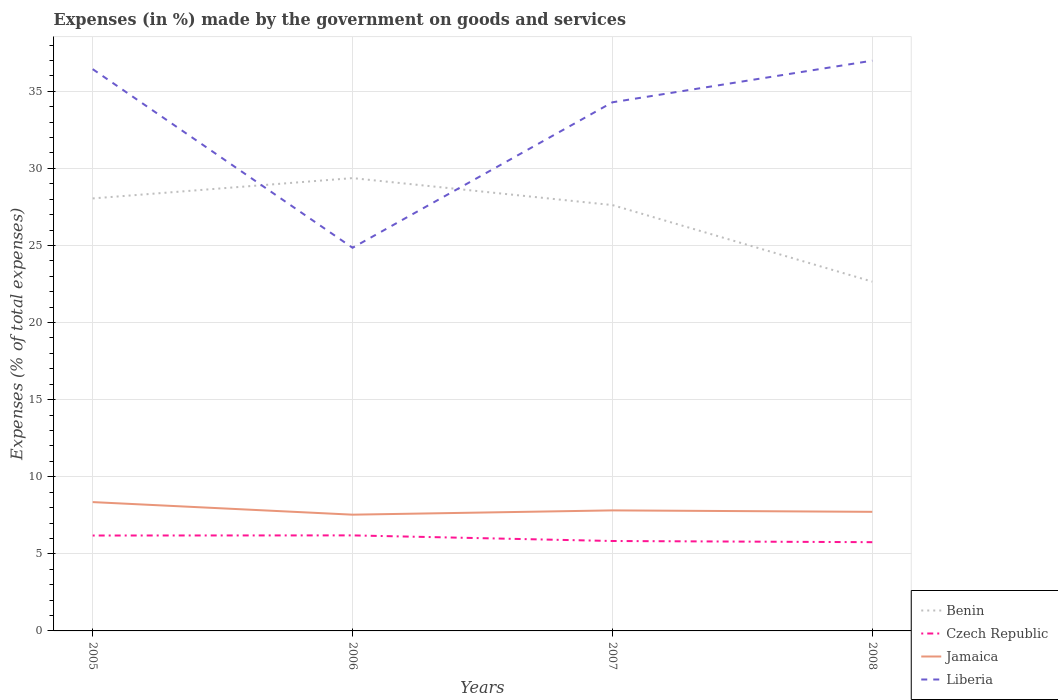How many different coloured lines are there?
Your answer should be very brief. 4. Does the line corresponding to Czech Republic intersect with the line corresponding to Benin?
Ensure brevity in your answer.  No. Across all years, what is the maximum percentage of expenses made by the government on goods and services in Jamaica?
Your answer should be very brief. 7.54. In which year was the percentage of expenses made by the government on goods and services in Czech Republic maximum?
Offer a very short reply. 2008. What is the total percentage of expenses made by the government on goods and services in Czech Republic in the graph?
Your response must be concise. 0.08. What is the difference between the highest and the second highest percentage of expenses made by the government on goods and services in Czech Republic?
Provide a succinct answer. 0.44. What is the difference between the highest and the lowest percentage of expenses made by the government on goods and services in Benin?
Keep it short and to the point. 3. How many lines are there?
Your answer should be very brief. 4. What is the difference between two consecutive major ticks on the Y-axis?
Offer a terse response. 5. Are the values on the major ticks of Y-axis written in scientific E-notation?
Your answer should be very brief. No. Does the graph contain any zero values?
Offer a very short reply. No. Does the graph contain grids?
Your answer should be very brief. Yes. Where does the legend appear in the graph?
Provide a short and direct response. Bottom right. How many legend labels are there?
Give a very brief answer. 4. What is the title of the graph?
Give a very brief answer. Expenses (in %) made by the government on goods and services. Does "Ghana" appear as one of the legend labels in the graph?
Offer a terse response. No. What is the label or title of the X-axis?
Offer a terse response. Years. What is the label or title of the Y-axis?
Your answer should be compact. Expenses (% of total expenses). What is the Expenses (% of total expenses) in Benin in 2005?
Ensure brevity in your answer.  28.05. What is the Expenses (% of total expenses) of Czech Republic in 2005?
Offer a terse response. 6.19. What is the Expenses (% of total expenses) of Jamaica in 2005?
Offer a very short reply. 8.36. What is the Expenses (% of total expenses) in Liberia in 2005?
Ensure brevity in your answer.  36.44. What is the Expenses (% of total expenses) of Benin in 2006?
Make the answer very short. 29.37. What is the Expenses (% of total expenses) in Czech Republic in 2006?
Provide a short and direct response. 6.2. What is the Expenses (% of total expenses) in Jamaica in 2006?
Provide a short and direct response. 7.54. What is the Expenses (% of total expenses) of Liberia in 2006?
Keep it short and to the point. 24.85. What is the Expenses (% of total expenses) of Benin in 2007?
Provide a short and direct response. 27.62. What is the Expenses (% of total expenses) of Czech Republic in 2007?
Your response must be concise. 5.83. What is the Expenses (% of total expenses) of Jamaica in 2007?
Provide a short and direct response. 7.82. What is the Expenses (% of total expenses) in Liberia in 2007?
Offer a terse response. 34.29. What is the Expenses (% of total expenses) in Benin in 2008?
Provide a short and direct response. 22.66. What is the Expenses (% of total expenses) in Czech Republic in 2008?
Keep it short and to the point. 5.76. What is the Expenses (% of total expenses) of Jamaica in 2008?
Keep it short and to the point. 7.72. What is the Expenses (% of total expenses) in Liberia in 2008?
Offer a very short reply. 36.99. Across all years, what is the maximum Expenses (% of total expenses) in Benin?
Keep it short and to the point. 29.37. Across all years, what is the maximum Expenses (% of total expenses) in Czech Republic?
Ensure brevity in your answer.  6.2. Across all years, what is the maximum Expenses (% of total expenses) of Jamaica?
Ensure brevity in your answer.  8.36. Across all years, what is the maximum Expenses (% of total expenses) of Liberia?
Your response must be concise. 36.99. Across all years, what is the minimum Expenses (% of total expenses) in Benin?
Offer a very short reply. 22.66. Across all years, what is the minimum Expenses (% of total expenses) of Czech Republic?
Offer a terse response. 5.76. Across all years, what is the minimum Expenses (% of total expenses) in Jamaica?
Provide a succinct answer. 7.54. Across all years, what is the minimum Expenses (% of total expenses) of Liberia?
Provide a succinct answer. 24.85. What is the total Expenses (% of total expenses) in Benin in the graph?
Ensure brevity in your answer.  107.7. What is the total Expenses (% of total expenses) in Czech Republic in the graph?
Your answer should be compact. 23.97. What is the total Expenses (% of total expenses) in Jamaica in the graph?
Provide a succinct answer. 31.44. What is the total Expenses (% of total expenses) in Liberia in the graph?
Provide a short and direct response. 132.57. What is the difference between the Expenses (% of total expenses) in Benin in 2005 and that in 2006?
Provide a short and direct response. -1.32. What is the difference between the Expenses (% of total expenses) of Czech Republic in 2005 and that in 2006?
Offer a very short reply. -0.01. What is the difference between the Expenses (% of total expenses) in Jamaica in 2005 and that in 2006?
Offer a very short reply. 0.82. What is the difference between the Expenses (% of total expenses) in Liberia in 2005 and that in 2006?
Your response must be concise. 11.59. What is the difference between the Expenses (% of total expenses) in Benin in 2005 and that in 2007?
Your response must be concise. 0.43. What is the difference between the Expenses (% of total expenses) in Czech Republic in 2005 and that in 2007?
Your answer should be compact. 0.36. What is the difference between the Expenses (% of total expenses) in Jamaica in 2005 and that in 2007?
Your answer should be very brief. 0.54. What is the difference between the Expenses (% of total expenses) of Liberia in 2005 and that in 2007?
Make the answer very short. 2.15. What is the difference between the Expenses (% of total expenses) in Benin in 2005 and that in 2008?
Provide a succinct answer. 5.4. What is the difference between the Expenses (% of total expenses) in Czech Republic in 2005 and that in 2008?
Give a very brief answer. 0.43. What is the difference between the Expenses (% of total expenses) in Jamaica in 2005 and that in 2008?
Offer a very short reply. 0.63. What is the difference between the Expenses (% of total expenses) in Liberia in 2005 and that in 2008?
Provide a succinct answer. -0.55. What is the difference between the Expenses (% of total expenses) in Benin in 2006 and that in 2007?
Your answer should be compact. 1.75. What is the difference between the Expenses (% of total expenses) of Czech Republic in 2006 and that in 2007?
Offer a terse response. 0.36. What is the difference between the Expenses (% of total expenses) of Jamaica in 2006 and that in 2007?
Provide a short and direct response. -0.28. What is the difference between the Expenses (% of total expenses) of Liberia in 2006 and that in 2007?
Provide a succinct answer. -9.44. What is the difference between the Expenses (% of total expenses) in Benin in 2006 and that in 2008?
Your response must be concise. 6.71. What is the difference between the Expenses (% of total expenses) in Czech Republic in 2006 and that in 2008?
Offer a very short reply. 0.44. What is the difference between the Expenses (% of total expenses) of Jamaica in 2006 and that in 2008?
Your response must be concise. -0.18. What is the difference between the Expenses (% of total expenses) of Liberia in 2006 and that in 2008?
Your response must be concise. -12.14. What is the difference between the Expenses (% of total expenses) in Benin in 2007 and that in 2008?
Your answer should be very brief. 4.97. What is the difference between the Expenses (% of total expenses) in Czech Republic in 2007 and that in 2008?
Ensure brevity in your answer.  0.08. What is the difference between the Expenses (% of total expenses) of Jamaica in 2007 and that in 2008?
Make the answer very short. 0.09. What is the difference between the Expenses (% of total expenses) of Liberia in 2007 and that in 2008?
Ensure brevity in your answer.  -2.7. What is the difference between the Expenses (% of total expenses) in Benin in 2005 and the Expenses (% of total expenses) in Czech Republic in 2006?
Keep it short and to the point. 21.86. What is the difference between the Expenses (% of total expenses) of Benin in 2005 and the Expenses (% of total expenses) of Jamaica in 2006?
Ensure brevity in your answer.  20.51. What is the difference between the Expenses (% of total expenses) in Benin in 2005 and the Expenses (% of total expenses) in Liberia in 2006?
Keep it short and to the point. 3.2. What is the difference between the Expenses (% of total expenses) in Czech Republic in 2005 and the Expenses (% of total expenses) in Jamaica in 2006?
Offer a very short reply. -1.35. What is the difference between the Expenses (% of total expenses) in Czech Republic in 2005 and the Expenses (% of total expenses) in Liberia in 2006?
Provide a succinct answer. -18.66. What is the difference between the Expenses (% of total expenses) in Jamaica in 2005 and the Expenses (% of total expenses) in Liberia in 2006?
Provide a short and direct response. -16.5. What is the difference between the Expenses (% of total expenses) in Benin in 2005 and the Expenses (% of total expenses) in Czech Republic in 2007?
Ensure brevity in your answer.  22.22. What is the difference between the Expenses (% of total expenses) in Benin in 2005 and the Expenses (% of total expenses) in Jamaica in 2007?
Make the answer very short. 20.23. What is the difference between the Expenses (% of total expenses) in Benin in 2005 and the Expenses (% of total expenses) in Liberia in 2007?
Ensure brevity in your answer.  -6.24. What is the difference between the Expenses (% of total expenses) of Czech Republic in 2005 and the Expenses (% of total expenses) of Jamaica in 2007?
Keep it short and to the point. -1.63. What is the difference between the Expenses (% of total expenses) of Czech Republic in 2005 and the Expenses (% of total expenses) of Liberia in 2007?
Offer a terse response. -28.1. What is the difference between the Expenses (% of total expenses) of Jamaica in 2005 and the Expenses (% of total expenses) of Liberia in 2007?
Your response must be concise. -25.93. What is the difference between the Expenses (% of total expenses) of Benin in 2005 and the Expenses (% of total expenses) of Czech Republic in 2008?
Provide a succinct answer. 22.3. What is the difference between the Expenses (% of total expenses) in Benin in 2005 and the Expenses (% of total expenses) in Jamaica in 2008?
Keep it short and to the point. 20.33. What is the difference between the Expenses (% of total expenses) in Benin in 2005 and the Expenses (% of total expenses) in Liberia in 2008?
Give a very brief answer. -8.94. What is the difference between the Expenses (% of total expenses) in Czech Republic in 2005 and the Expenses (% of total expenses) in Jamaica in 2008?
Provide a short and direct response. -1.54. What is the difference between the Expenses (% of total expenses) in Czech Republic in 2005 and the Expenses (% of total expenses) in Liberia in 2008?
Provide a succinct answer. -30.8. What is the difference between the Expenses (% of total expenses) in Jamaica in 2005 and the Expenses (% of total expenses) in Liberia in 2008?
Keep it short and to the point. -28.63. What is the difference between the Expenses (% of total expenses) of Benin in 2006 and the Expenses (% of total expenses) of Czech Republic in 2007?
Offer a very short reply. 23.54. What is the difference between the Expenses (% of total expenses) in Benin in 2006 and the Expenses (% of total expenses) in Jamaica in 2007?
Give a very brief answer. 21.55. What is the difference between the Expenses (% of total expenses) of Benin in 2006 and the Expenses (% of total expenses) of Liberia in 2007?
Provide a succinct answer. -4.92. What is the difference between the Expenses (% of total expenses) of Czech Republic in 2006 and the Expenses (% of total expenses) of Jamaica in 2007?
Make the answer very short. -1.62. What is the difference between the Expenses (% of total expenses) in Czech Republic in 2006 and the Expenses (% of total expenses) in Liberia in 2007?
Offer a terse response. -28.09. What is the difference between the Expenses (% of total expenses) of Jamaica in 2006 and the Expenses (% of total expenses) of Liberia in 2007?
Give a very brief answer. -26.75. What is the difference between the Expenses (% of total expenses) of Benin in 2006 and the Expenses (% of total expenses) of Czech Republic in 2008?
Your answer should be very brief. 23.61. What is the difference between the Expenses (% of total expenses) in Benin in 2006 and the Expenses (% of total expenses) in Jamaica in 2008?
Offer a very short reply. 21.65. What is the difference between the Expenses (% of total expenses) of Benin in 2006 and the Expenses (% of total expenses) of Liberia in 2008?
Keep it short and to the point. -7.62. What is the difference between the Expenses (% of total expenses) in Czech Republic in 2006 and the Expenses (% of total expenses) in Jamaica in 2008?
Your response must be concise. -1.53. What is the difference between the Expenses (% of total expenses) in Czech Republic in 2006 and the Expenses (% of total expenses) in Liberia in 2008?
Make the answer very short. -30.79. What is the difference between the Expenses (% of total expenses) of Jamaica in 2006 and the Expenses (% of total expenses) of Liberia in 2008?
Your answer should be very brief. -29.45. What is the difference between the Expenses (% of total expenses) of Benin in 2007 and the Expenses (% of total expenses) of Czech Republic in 2008?
Ensure brevity in your answer.  21.87. What is the difference between the Expenses (% of total expenses) of Benin in 2007 and the Expenses (% of total expenses) of Jamaica in 2008?
Provide a short and direct response. 19.9. What is the difference between the Expenses (% of total expenses) in Benin in 2007 and the Expenses (% of total expenses) in Liberia in 2008?
Ensure brevity in your answer.  -9.37. What is the difference between the Expenses (% of total expenses) of Czech Republic in 2007 and the Expenses (% of total expenses) of Jamaica in 2008?
Give a very brief answer. -1.89. What is the difference between the Expenses (% of total expenses) in Czech Republic in 2007 and the Expenses (% of total expenses) in Liberia in 2008?
Offer a terse response. -31.16. What is the difference between the Expenses (% of total expenses) in Jamaica in 2007 and the Expenses (% of total expenses) in Liberia in 2008?
Give a very brief answer. -29.17. What is the average Expenses (% of total expenses) in Benin per year?
Ensure brevity in your answer.  26.93. What is the average Expenses (% of total expenses) in Czech Republic per year?
Provide a succinct answer. 5.99. What is the average Expenses (% of total expenses) in Jamaica per year?
Your answer should be compact. 7.86. What is the average Expenses (% of total expenses) of Liberia per year?
Provide a succinct answer. 33.14. In the year 2005, what is the difference between the Expenses (% of total expenses) of Benin and Expenses (% of total expenses) of Czech Republic?
Provide a succinct answer. 21.86. In the year 2005, what is the difference between the Expenses (% of total expenses) in Benin and Expenses (% of total expenses) in Jamaica?
Offer a very short reply. 19.7. In the year 2005, what is the difference between the Expenses (% of total expenses) of Benin and Expenses (% of total expenses) of Liberia?
Give a very brief answer. -8.39. In the year 2005, what is the difference between the Expenses (% of total expenses) in Czech Republic and Expenses (% of total expenses) in Jamaica?
Your response must be concise. -2.17. In the year 2005, what is the difference between the Expenses (% of total expenses) in Czech Republic and Expenses (% of total expenses) in Liberia?
Provide a succinct answer. -30.25. In the year 2005, what is the difference between the Expenses (% of total expenses) in Jamaica and Expenses (% of total expenses) in Liberia?
Offer a terse response. -28.08. In the year 2006, what is the difference between the Expenses (% of total expenses) in Benin and Expenses (% of total expenses) in Czech Republic?
Make the answer very short. 23.17. In the year 2006, what is the difference between the Expenses (% of total expenses) of Benin and Expenses (% of total expenses) of Jamaica?
Offer a terse response. 21.83. In the year 2006, what is the difference between the Expenses (% of total expenses) in Benin and Expenses (% of total expenses) in Liberia?
Provide a short and direct response. 4.52. In the year 2006, what is the difference between the Expenses (% of total expenses) in Czech Republic and Expenses (% of total expenses) in Jamaica?
Ensure brevity in your answer.  -1.34. In the year 2006, what is the difference between the Expenses (% of total expenses) of Czech Republic and Expenses (% of total expenses) of Liberia?
Provide a short and direct response. -18.66. In the year 2006, what is the difference between the Expenses (% of total expenses) of Jamaica and Expenses (% of total expenses) of Liberia?
Give a very brief answer. -17.31. In the year 2007, what is the difference between the Expenses (% of total expenses) in Benin and Expenses (% of total expenses) in Czech Republic?
Your response must be concise. 21.79. In the year 2007, what is the difference between the Expenses (% of total expenses) of Benin and Expenses (% of total expenses) of Jamaica?
Your answer should be compact. 19.8. In the year 2007, what is the difference between the Expenses (% of total expenses) of Benin and Expenses (% of total expenses) of Liberia?
Make the answer very short. -6.67. In the year 2007, what is the difference between the Expenses (% of total expenses) in Czech Republic and Expenses (% of total expenses) in Jamaica?
Your response must be concise. -1.99. In the year 2007, what is the difference between the Expenses (% of total expenses) in Czech Republic and Expenses (% of total expenses) in Liberia?
Give a very brief answer. -28.46. In the year 2007, what is the difference between the Expenses (% of total expenses) of Jamaica and Expenses (% of total expenses) of Liberia?
Ensure brevity in your answer.  -26.47. In the year 2008, what is the difference between the Expenses (% of total expenses) in Benin and Expenses (% of total expenses) in Czech Republic?
Offer a terse response. 16.9. In the year 2008, what is the difference between the Expenses (% of total expenses) of Benin and Expenses (% of total expenses) of Jamaica?
Offer a very short reply. 14.93. In the year 2008, what is the difference between the Expenses (% of total expenses) in Benin and Expenses (% of total expenses) in Liberia?
Provide a succinct answer. -14.33. In the year 2008, what is the difference between the Expenses (% of total expenses) in Czech Republic and Expenses (% of total expenses) in Jamaica?
Your answer should be very brief. -1.97. In the year 2008, what is the difference between the Expenses (% of total expenses) of Czech Republic and Expenses (% of total expenses) of Liberia?
Offer a terse response. -31.23. In the year 2008, what is the difference between the Expenses (% of total expenses) of Jamaica and Expenses (% of total expenses) of Liberia?
Keep it short and to the point. -29.26. What is the ratio of the Expenses (% of total expenses) of Benin in 2005 to that in 2006?
Make the answer very short. 0.96. What is the ratio of the Expenses (% of total expenses) of Czech Republic in 2005 to that in 2006?
Make the answer very short. 1. What is the ratio of the Expenses (% of total expenses) of Jamaica in 2005 to that in 2006?
Provide a short and direct response. 1.11. What is the ratio of the Expenses (% of total expenses) of Liberia in 2005 to that in 2006?
Your answer should be compact. 1.47. What is the ratio of the Expenses (% of total expenses) in Benin in 2005 to that in 2007?
Make the answer very short. 1.02. What is the ratio of the Expenses (% of total expenses) in Czech Republic in 2005 to that in 2007?
Offer a very short reply. 1.06. What is the ratio of the Expenses (% of total expenses) in Jamaica in 2005 to that in 2007?
Make the answer very short. 1.07. What is the ratio of the Expenses (% of total expenses) of Liberia in 2005 to that in 2007?
Offer a very short reply. 1.06. What is the ratio of the Expenses (% of total expenses) of Benin in 2005 to that in 2008?
Offer a terse response. 1.24. What is the ratio of the Expenses (% of total expenses) in Czech Republic in 2005 to that in 2008?
Keep it short and to the point. 1.07. What is the ratio of the Expenses (% of total expenses) in Jamaica in 2005 to that in 2008?
Offer a terse response. 1.08. What is the ratio of the Expenses (% of total expenses) in Liberia in 2005 to that in 2008?
Keep it short and to the point. 0.99. What is the ratio of the Expenses (% of total expenses) of Benin in 2006 to that in 2007?
Provide a short and direct response. 1.06. What is the ratio of the Expenses (% of total expenses) in Czech Republic in 2006 to that in 2007?
Your answer should be very brief. 1.06. What is the ratio of the Expenses (% of total expenses) of Jamaica in 2006 to that in 2007?
Offer a terse response. 0.96. What is the ratio of the Expenses (% of total expenses) in Liberia in 2006 to that in 2007?
Make the answer very short. 0.72. What is the ratio of the Expenses (% of total expenses) of Benin in 2006 to that in 2008?
Your answer should be compact. 1.3. What is the ratio of the Expenses (% of total expenses) of Czech Republic in 2006 to that in 2008?
Provide a succinct answer. 1.08. What is the ratio of the Expenses (% of total expenses) of Jamaica in 2006 to that in 2008?
Give a very brief answer. 0.98. What is the ratio of the Expenses (% of total expenses) of Liberia in 2006 to that in 2008?
Your response must be concise. 0.67. What is the ratio of the Expenses (% of total expenses) of Benin in 2007 to that in 2008?
Make the answer very short. 1.22. What is the ratio of the Expenses (% of total expenses) of Czech Republic in 2007 to that in 2008?
Your answer should be very brief. 1.01. What is the ratio of the Expenses (% of total expenses) in Jamaica in 2007 to that in 2008?
Offer a terse response. 1.01. What is the ratio of the Expenses (% of total expenses) in Liberia in 2007 to that in 2008?
Provide a succinct answer. 0.93. What is the difference between the highest and the second highest Expenses (% of total expenses) in Benin?
Provide a short and direct response. 1.32. What is the difference between the highest and the second highest Expenses (% of total expenses) in Czech Republic?
Give a very brief answer. 0.01. What is the difference between the highest and the second highest Expenses (% of total expenses) of Jamaica?
Provide a short and direct response. 0.54. What is the difference between the highest and the second highest Expenses (% of total expenses) of Liberia?
Keep it short and to the point. 0.55. What is the difference between the highest and the lowest Expenses (% of total expenses) of Benin?
Your answer should be very brief. 6.71. What is the difference between the highest and the lowest Expenses (% of total expenses) in Czech Republic?
Your response must be concise. 0.44. What is the difference between the highest and the lowest Expenses (% of total expenses) in Jamaica?
Keep it short and to the point. 0.82. What is the difference between the highest and the lowest Expenses (% of total expenses) of Liberia?
Provide a short and direct response. 12.14. 